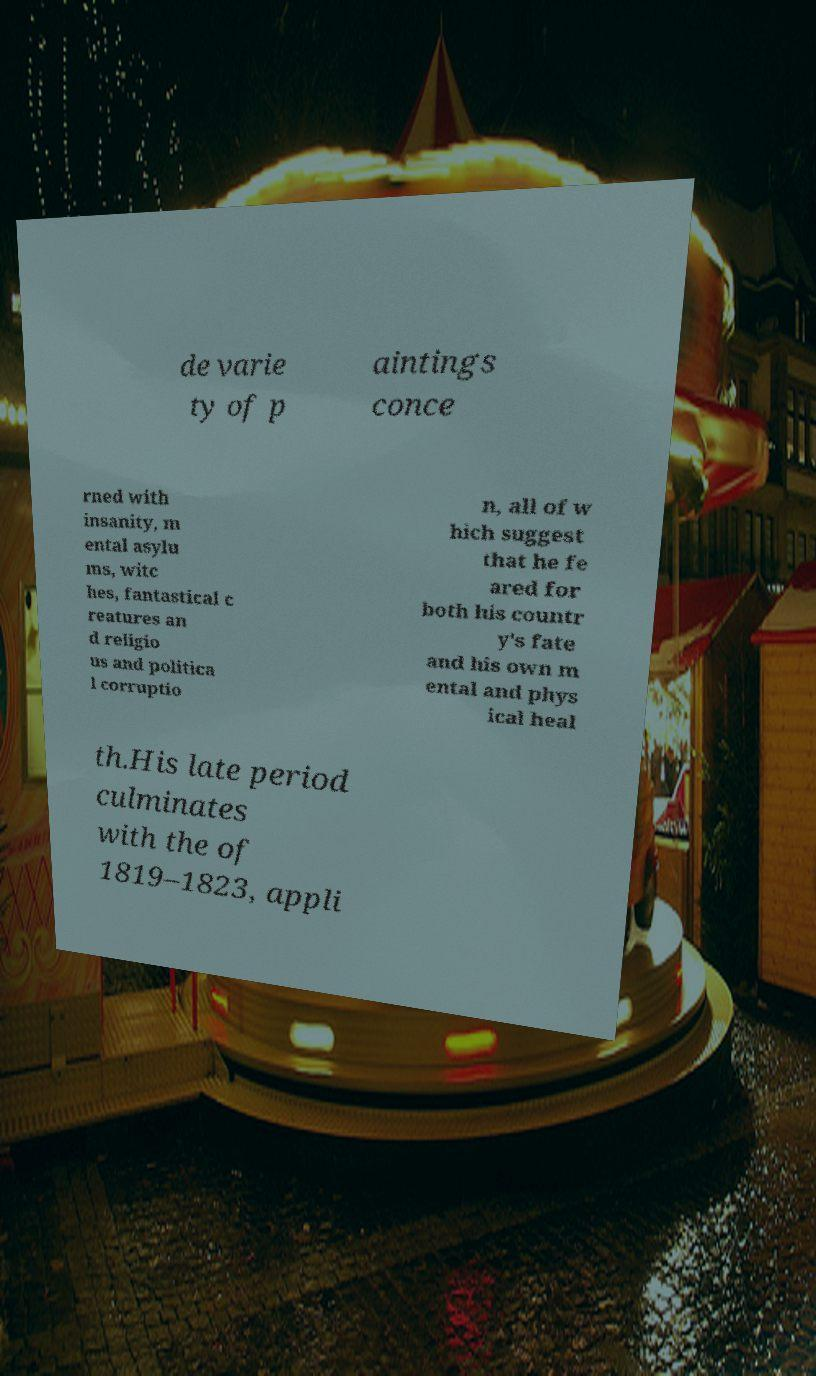Can you accurately transcribe the text from the provided image for me? de varie ty of p aintings conce rned with insanity, m ental asylu ms, witc hes, fantastical c reatures an d religio us and politica l corruptio n, all of w hich suggest that he fe ared for both his countr y's fate and his own m ental and phys ical heal th.His late period culminates with the of 1819–1823, appli 